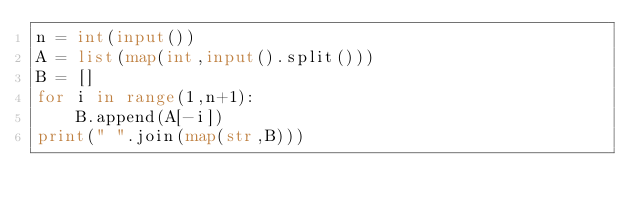Convert code to text. <code><loc_0><loc_0><loc_500><loc_500><_Python_>n = int(input())
A = list(map(int,input().split()))
B = []
for i in range(1,n+1):
    B.append(A[-i])
print(" ".join(map(str,B)))

</code> 